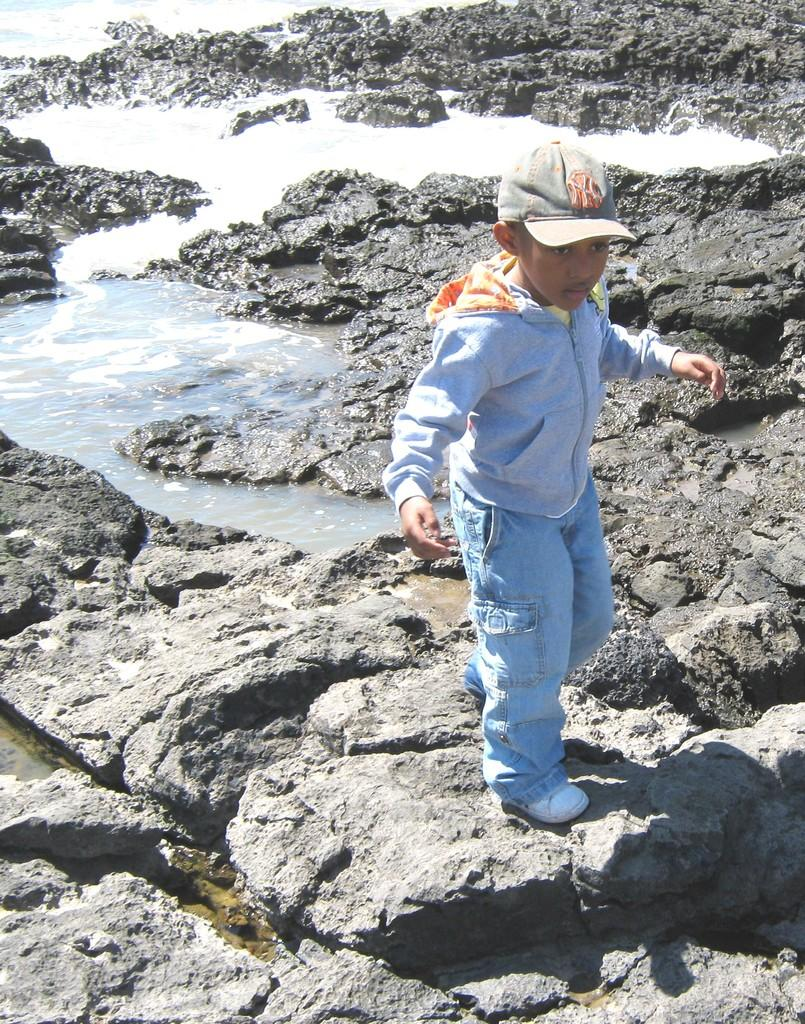Who is present in the image? There is a boy in the image. What is the boy doing in the image? The boy is standing on a rock. What can be seen behind the boy? There is water visible behind the boy. What type of cap is the deer wearing in the image? There is no deer present in the image, and therefore no cap or any other accessories can be observed. 